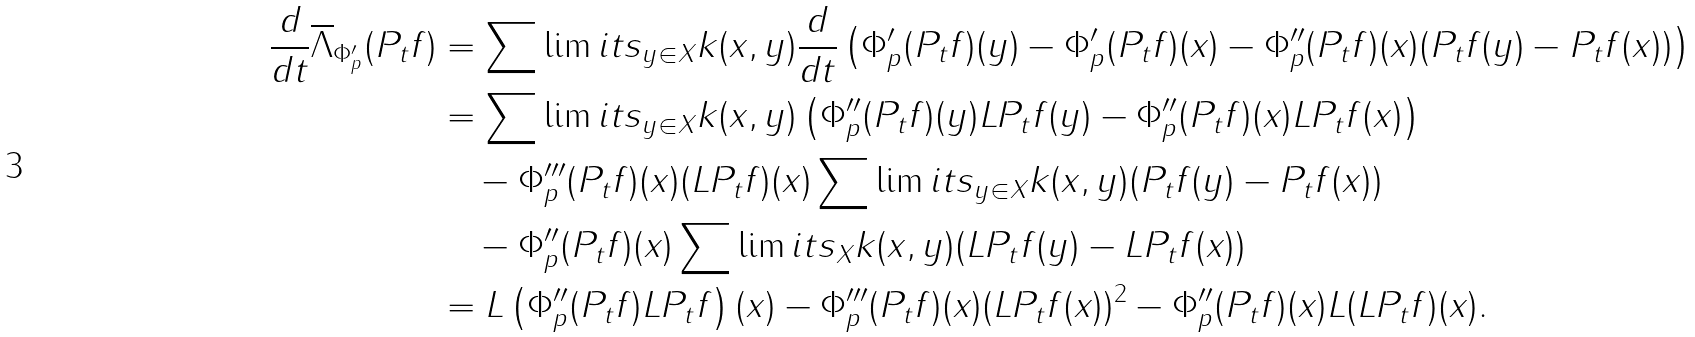<formula> <loc_0><loc_0><loc_500><loc_500>\frac { d } { d t } \overline { \Lambda } _ { \Phi _ { p } ^ { \prime } } ( P _ { t } f ) & = \sum \lim i t s _ { y \in X } k ( x , y ) \frac { d } { d t } \left ( \Phi _ { p } ^ { \prime } ( P _ { t } f ) ( y ) - \Phi _ { p } ^ { \prime } ( P _ { t } f ) ( x ) - \Phi _ { p } ^ { \prime \prime } ( P _ { t } f ) ( x ) ( P _ { t } f ( y ) - P _ { t } f ( x ) ) \right ) \\ & = \sum \lim i t s _ { y \in X } k ( x , y ) \left ( \Phi _ { p } ^ { \prime \prime } ( P _ { t } f ) ( y ) L P _ { t } f ( y ) - \Phi _ { p } ^ { \prime \prime } ( P _ { t } f ) ( x ) L P _ { t } f ( x ) \right ) \\ & \quad - \Phi _ { p } ^ { \prime \prime \prime } ( P _ { t } f ) ( x ) ( L P _ { t } f ) ( x ) \sum \lim i t s _ { y \in X } k ( x , y ) ( P _ { t } f ( y ) - P _ { t } f ( x ) ) \\ & \quad - \Phi _ { p } ^ { \prime \prime } ( P _ { t } f ) ( x ) \sum \lim i t s _ { X } k ( x , y ) ( L P _ { t } f ( y ) - L P _ { t } f ( x ) ) \\ & = L \left ( \Phi _ { p } ^ { \prime \prime } ( P _ { t } f ) L P _ { t } f \right ) ( x ) - \Phi _ { p } ^ { \prime \prime \prime } ( P _ { t } f ) ( x ) ( L P _ { t } f ( x ) ) ^ { 2 } - \Phi _ { p } ^ { \prime \prime } ( P _ { t } f ) ( x ) L ( L P _ { t } f ) ( x ) .</formula> 